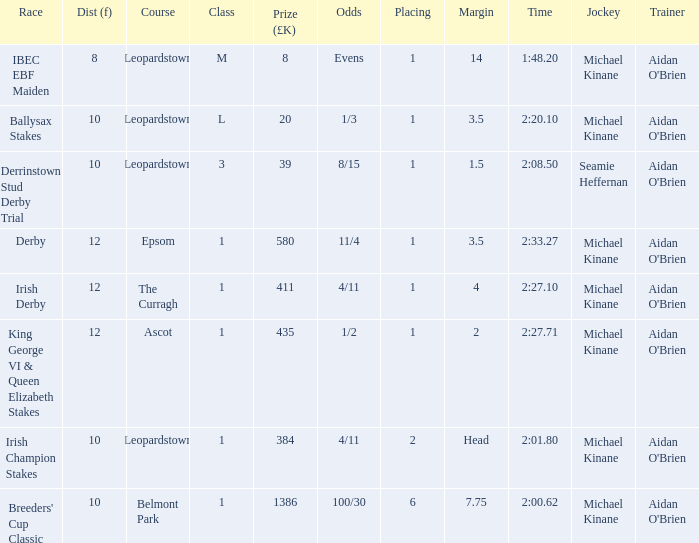Which Dist (f) has a Race of irish derby? 12.0. 